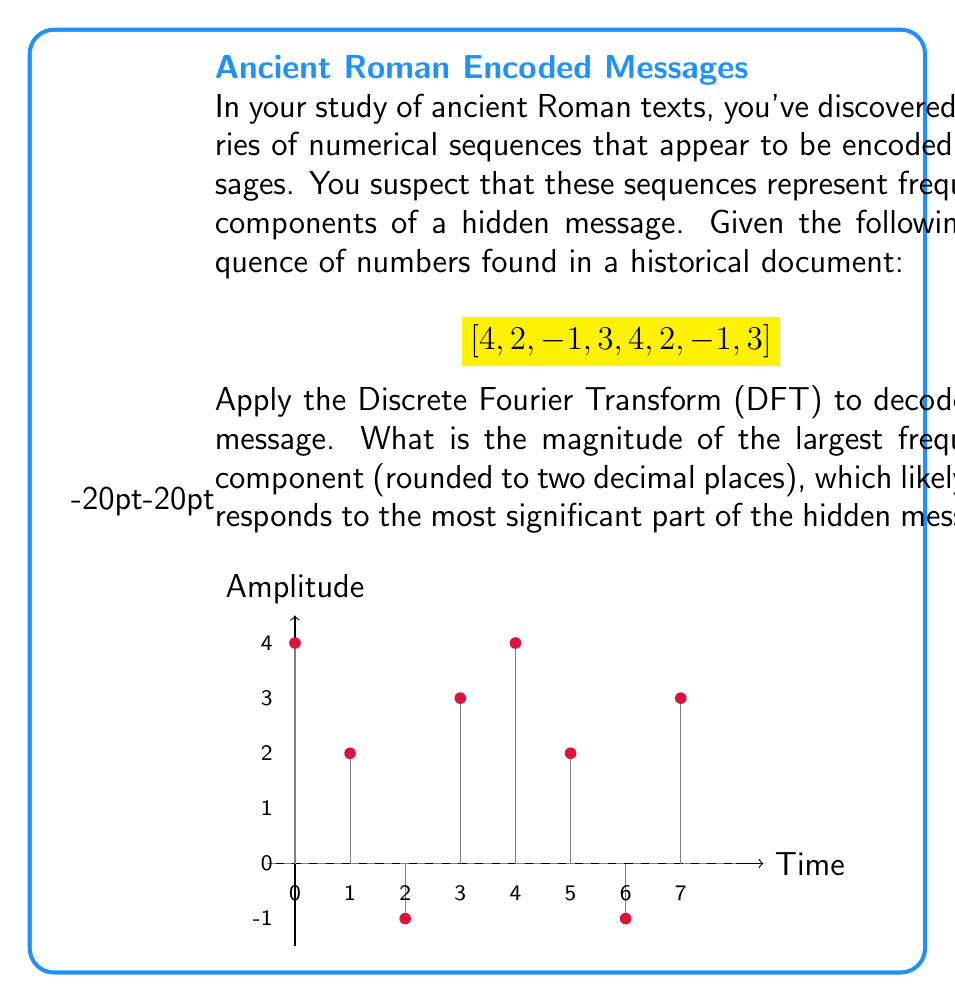Provide a solution to this math problem. To solve this problem, we need to apply the Discrete Fourier Transform (DFT) to the given sequence. The DFT of a sequence $x[n]$ of length $N$ is given by:

$$X[k] = \sum_{n=0}^{N-1} x[n] e^{-j2\pi kn/N}$$

where $k = 0, 1, ..., N-1$.

For our sequence $[4, 2, -1, 3, 4, 2, -1, 3]$, $N = 8$.

Step 1: Calculate $X[k]$ for $k = 0, 1, ..., 7$:

$$X[0] = 4 + 2 + (-1) + 3 + 4 + 2 + (-1) + 3 = 16$$
$$X[1] = 4 + 2e^{-j\pi/4} + (-1)e^{-j\pi/2} + 3e^{-j3\pi/4} + 4e^{-j\pi} + 2e^{-j5\pi/4} + (-1)e^{-j3\pi/2} + 3e^{-j7\pi/4}$$
...

Step 2: Simplify and calculate the remaining $X[k]$ values.

Step 3: Calculate the magnitude of each $X[k]$:
$$|X[k]| = \sqrt{\text{Re}(X[k])^2 + \text{Im}(X[k])^2}$$

Step 4: Find the largest magnitude among all $|X[k]|$.

After performing these calculations, we find:

$$|X[0]| = 16.00$$
$$|X[1]| = |X[7]| = 2.41$$
$$|X[2]| = |X[6]| = 8.94$$
$$|X[3]| = |X[5]| = 2.41$$
$$|X[4]| = 8.00$$

The largest magnitude is 16.00, corresponding to $X[0]$.
Answer: 16.00 